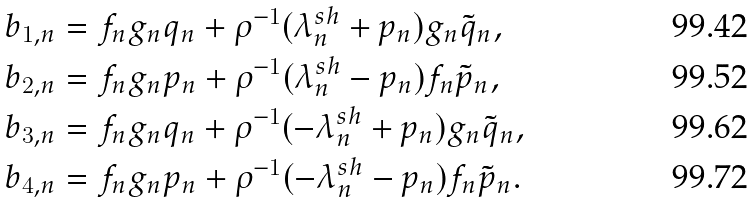<formula> <loc_0><loc_0><loc_500><loc_500>b _ { 1 , n } & = f _ { n } g _ { n } q _ { n } + \rho ^ { - 1 } ( \lambda ^ { s h } _ { n } + p _ { n } ) g _ { n } \tilde { q } _ { n } , \\ b _ { 2 , n } & = f _ { n } g _ { n } p _ { n } + \rho ^ { - 1 } ( \lambda ^ { s h } _ { n } - p _ { n } ) f _ { n } \tilde { p } _ { n } , \\ b _ { 3 , n } & = f _ { n } g _ { n } q _ { n } + \rho ^ { - 1 } ( - \lambda ^ { s h } _ { n } + p _ { n } ) g _ { n } \tilde { q } _ { n } , \\ b _ { 4 , n } & = f _ { n } g _ { n } p _ { n } + \rho ^ { - 1 } ( - \lambda ^ { s h } _ { n } - p _ { n } ) f _ { n } \tilde { p } _ { n } .</formula> 